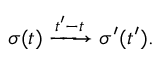Convert formula to latex. <formula><loc_0><loc_0><loc_500><loc_500>\sigma ( t ) \xrightarrow { { t ^ { \prime } } - t } \sigma ^ { \prime } ( { t ^ { \prime } } ) .</formula> 